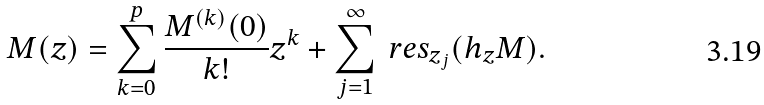<formula> <loc_0><loc_0><loc_500><loc_500>M ( z ) = \sum _ { k = 0 } ^ { p } \frac { M ^ { ( k ) } ( 0 ) } { k ! } z ^ { k } + \sum _ { j = 1 } ^ { \infty } \ r e s _ { z _ { j } } ( h _ { z } M ) .</formula> 